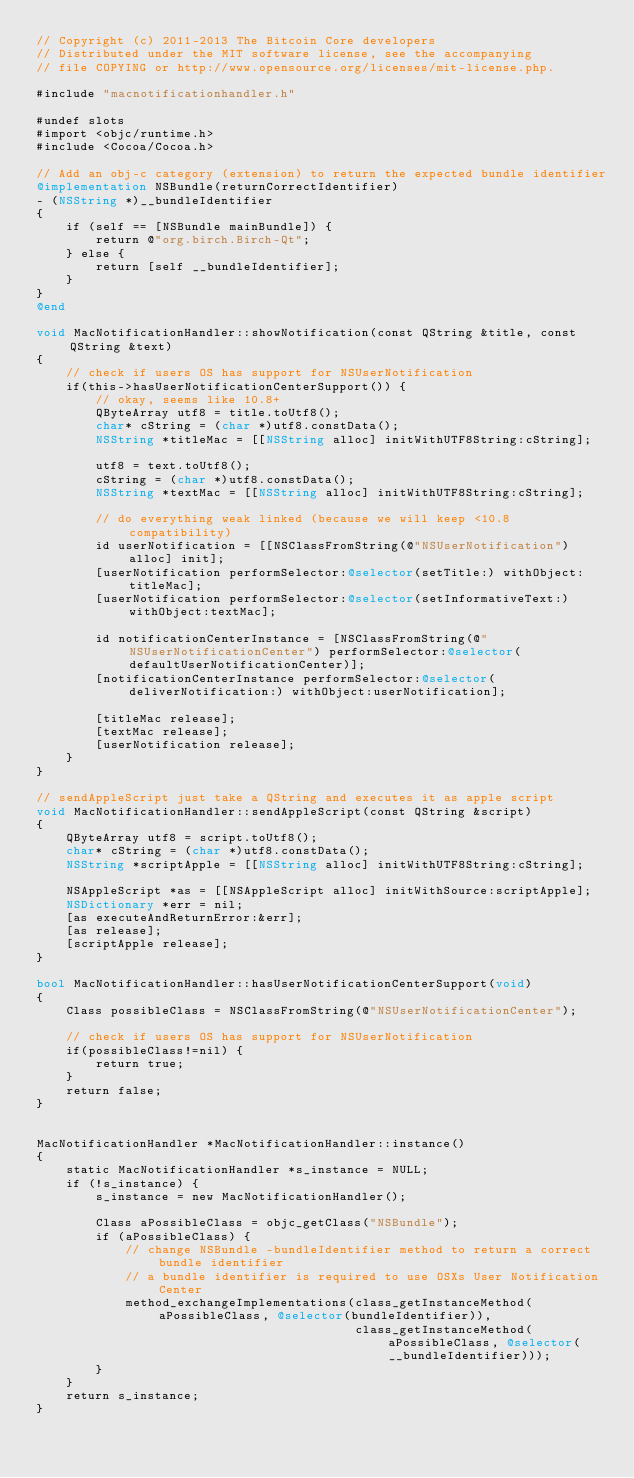Convert code to text. <code><loc_0><loc_0><loc_500><loc_500><_ObjectiveC_>// Copyright (c) 2011-2013 The Bitcoin Core developers
// Distributed under the MIT software license, see the accompanying
// file COPYING or http://www.opensource.org/licenses/mit-license.php.

#include "macnotificationhandler.h"

#undef slots
#import <objc/runtime.h>
#include <Cocoa/Cocoa.h>

// Add an obj-c category (extension) to return the expected bundle identifier
@implementation NSBundle(returnCorrectIdentifier)
- (NSString *)__bundleIdentifier
{
    if (self == [NSBundle mainBundle]) {
        return @"org.birch.Birch-Qt";
    } else {
        return [self __bundleIdentifier];
    }
}
@end

void MacNotificationHandler::showNotification(const QString &title, const QString &text)
{
    // check if users OS has support for NSUserNotification
    if(this->hasUserNotificationCenterSupport()) {
        // okay, seems like 10.8+
        QByteArray utf8 = title.toUtf8();
        char* cString = (char *)utf8.constData();
        NSString *titleMac = [[NSString alloc] initWithUTF8String:cString];

        utf8 = text.toUtf8();
        cString = (char *)utf8.constData();
        NSString *textMac = [[NSString alloc] initWithUTF8String:cString];

        // do everything weak linked (because we will keep <10.8 compatibility)
        id userNotification = [[NSClassFromString(@"NSUserNotification") alloc] init];
        [userNotification performSelector:@selector(setTitle:) withObject:titleMac];
        [userNotification performSelector:@selector(setInformativeText:) withObject:textMac];

        id notificationCenterInstance = [NSClassFromString(@"NSUserNotificationCenter") performSelector:@selector(defaultUserNotificationCenter)];
        [notificationCenterInstance performSelector:@selector(deliverNotification:) withObject:userNotification];

        [titleMac release];
        [textMac release];
        [userNotification release];
    }
}

// sendAppleScript just take a QString and executes it as apple script
void MacNotificationHandler::sendAppleScript(const QString &script)
{
    QByteArray utf8 = script.toUtf8();
    char* cString = (char *)utf8.constData();
    NSString *scriptApple = [[NSString alloc] initWithUTF8String:cString];

    NSAppleScript *as = [[NSAppleScript alloc] initWithSource:scriptApple];
    NSDictionary *err = nil;
    [as executeAndReturnError:&err];
    [as release];
    [scriptApple release];
}

bool MacNotificationHandler::hasUserNotificationCenterSupport(void)
{
    Class possibleClass = NSClassFromString(@"NSUserNotificationCenter");

    // check if users OS has support for NSUserNotification
    if(possibleClass!=nil) {
        return true;
    }
    return false;
}


MacNotificationHandler *MacNotificationHandler::instance()
{
    static MacNotificationHandler *s_instance = NULL;
    if (!s_instance) {
        s_instance = new MacNotificationHandler();
        
        Class aPossibleClass = objc_getClass("NSBundle");
        if (aPossibleClass) {
            // change NSBundle -bundleIdentifier method to return a correct bundle identifier
            // a bundle identifier is required to use OSXs User Notification Center
            method_exchangeImplementations(class_getInstanceMethod(aPossibleClass, @selector(bundleIdentifier)),
                                           class_getInstanceMethod(aPossibleClass, @selector(__bundleIdentifier)));
        }
    }
    return s_instance;
}
</code> 